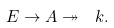<formula> <loc_0><loc_0><loc_500><loc_500>E \rightarrow A \twoheadrightarrow \ k .</formula> 